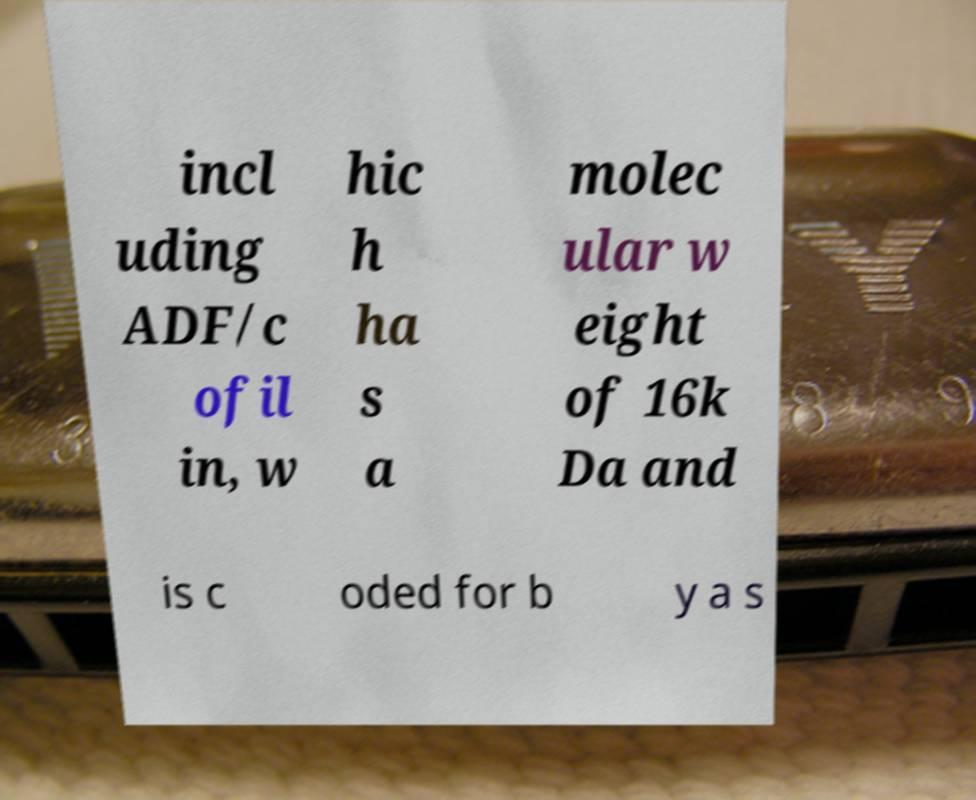Please identify and transcribe the text found in this image. incl uding ADF/c ofil in, w hic h ha s a molec ular w eight of 16k Da and is c oded for b y a s 